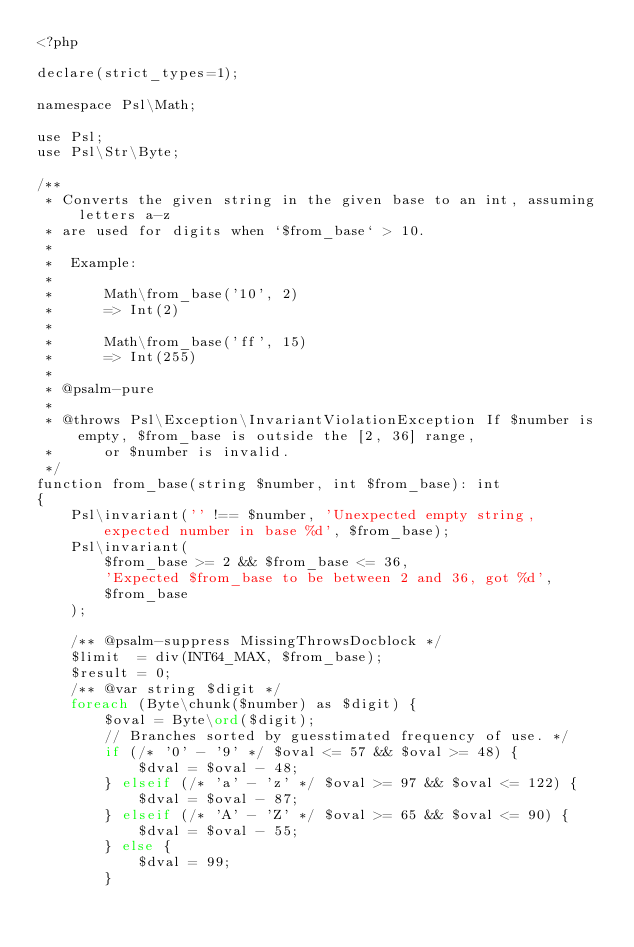Convert code to text. <code><loc_0><loc_0><loc_500><loc_500><_PHP_><?php

declare(strict_types=1);

namespace Psl\Math;

use Psl;
use Psl\Str\Byte;

/**
 * Converts the given string in the given base to an int, assuming letters a-z
 * are used for digits when `$from_base` > 10.
 *
 *  Example:
 *
 *      Math\from_base('10', 2)
 *      => Int(2)
 *
 *      Math\from_base('ff', 15)
 *      => Int(255)
 *
 * @psalm-pure
 *
 * @throws Psl\Exception\InvariantViolationException If $number is empty, $from_base is outside the [2, 36] range,
 *      or $number is invalid.
 */
function from_base(string $number, int $from_base): int
{
    Psl\invariant('' !== $number, 'Unexpected empty string, expected number in base %d', $from_base);
    Psl\invariant(
        $from_base >= 2 && $from_base <= 36,
        'Expected $from_base to be between 2 and 36, got %d',
        $from_base
    );

    /** @psalm-suppress MissingThrowsDocblock */
    $limit  = div(INT64_MAX, $from_base);
    $result = 0;
    /** @var string $digit */
    foreach (Byte\chunk($number) as $digit) {
        $oval = Byte\ord($digit);
        // Branches sorted by guesstimated frequency of use. */
        if (/* '0' - '9' */ $oval <= 57 && $oval >= 48) {
            $dval = $oval - 48;
        } elseif (/* 'a' - 'z' */ $oval >= 97 && $oval <= 122) {
            $dval = $oval - 87;
        } elseif (/* 'A' - 'Z' */ $oval >= 65 && $oval <= 90) {
            $dval = $oval - 55;
        } else {
            $dval = 99;
        }
</code> 